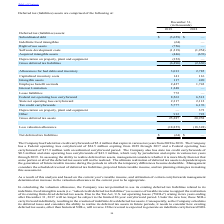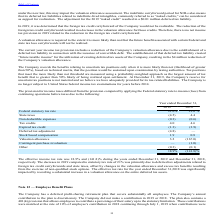According to Par Technology's financial document, When will the Federal tax credit carryforwards of $5.4 million expire? expire in various tax years from 2028 to 2038.. The document states: "eral tax credit carryforwards of $5.4 million that expire in various tax years from 2028 to 2038. The Company has a Federal operating loss carryforwar..." Also, When will the Federal tax credit carryforwards of $24.5 million expire? from 2029 through 2037. The document states: "ating loss carryforward of $24.5 million expiring from 2029 through 2037 and a Federal operating loss carryforward of $17.9 million with an unlimited ..." Also, How much is the state tax credit carryforwards and  state operating loss carryforwards respectively? The document shows two values: $0.3 million and $43.3 million. From the document: "million and state operating loss carryforwards of $43.3 million, which vary by jurisdiction and expire in various tax years through 2039. In assessing..." Also, can you calculate: What is the change in Software development costs between December 31, 2018 and 2019? Based on the calculation: 1,219-1,954, the result is -735 (in thousands). This is based on the information: "Software development costs (1,219) (1,954) Software development costs (1,219) (1,954)..." The key data points involved are: 1,219, 1,954. Also, can you calculate: What is the change in Acquired intangible assets between December 31, 2018 and 2019? Based on the calculation: 446-676, the result is -230 (in thousands). This is based on the information: "Acquired intangible assets (446) (676) Acquired intangible assets (446) (676)..." The key data points involved are: 446, 676. Also, can you calculate: What is the average Software development costs for December 31, 2018 and 2019? To answer this question, I need to perform calculations using the financial data. The calculation is: (1,219+1,954) / 2, which equals 1586.5 (in thousands). This is based on the information: "Software development costs (1,219) (1,954) Software development costs (1,219) (1,954)..." The key data points involved are: 1,219, 1,954. 